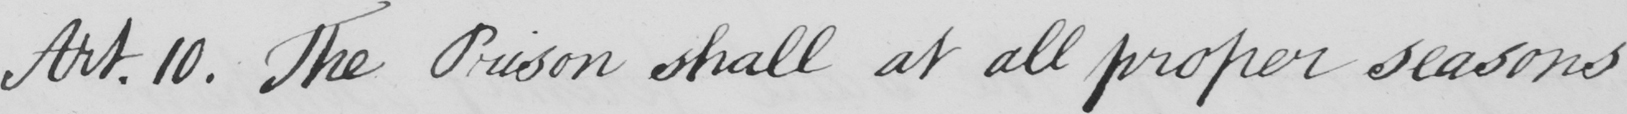Transcribe the text shown in this historical manuscript line. Art.10. The Prison shall at all proper seasons 